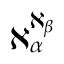<formula> <loc_0><loc_0><loc_500><loc_500>\aleph _ { \alpha } ^ { \aleph _ { \beta } }</formula> 